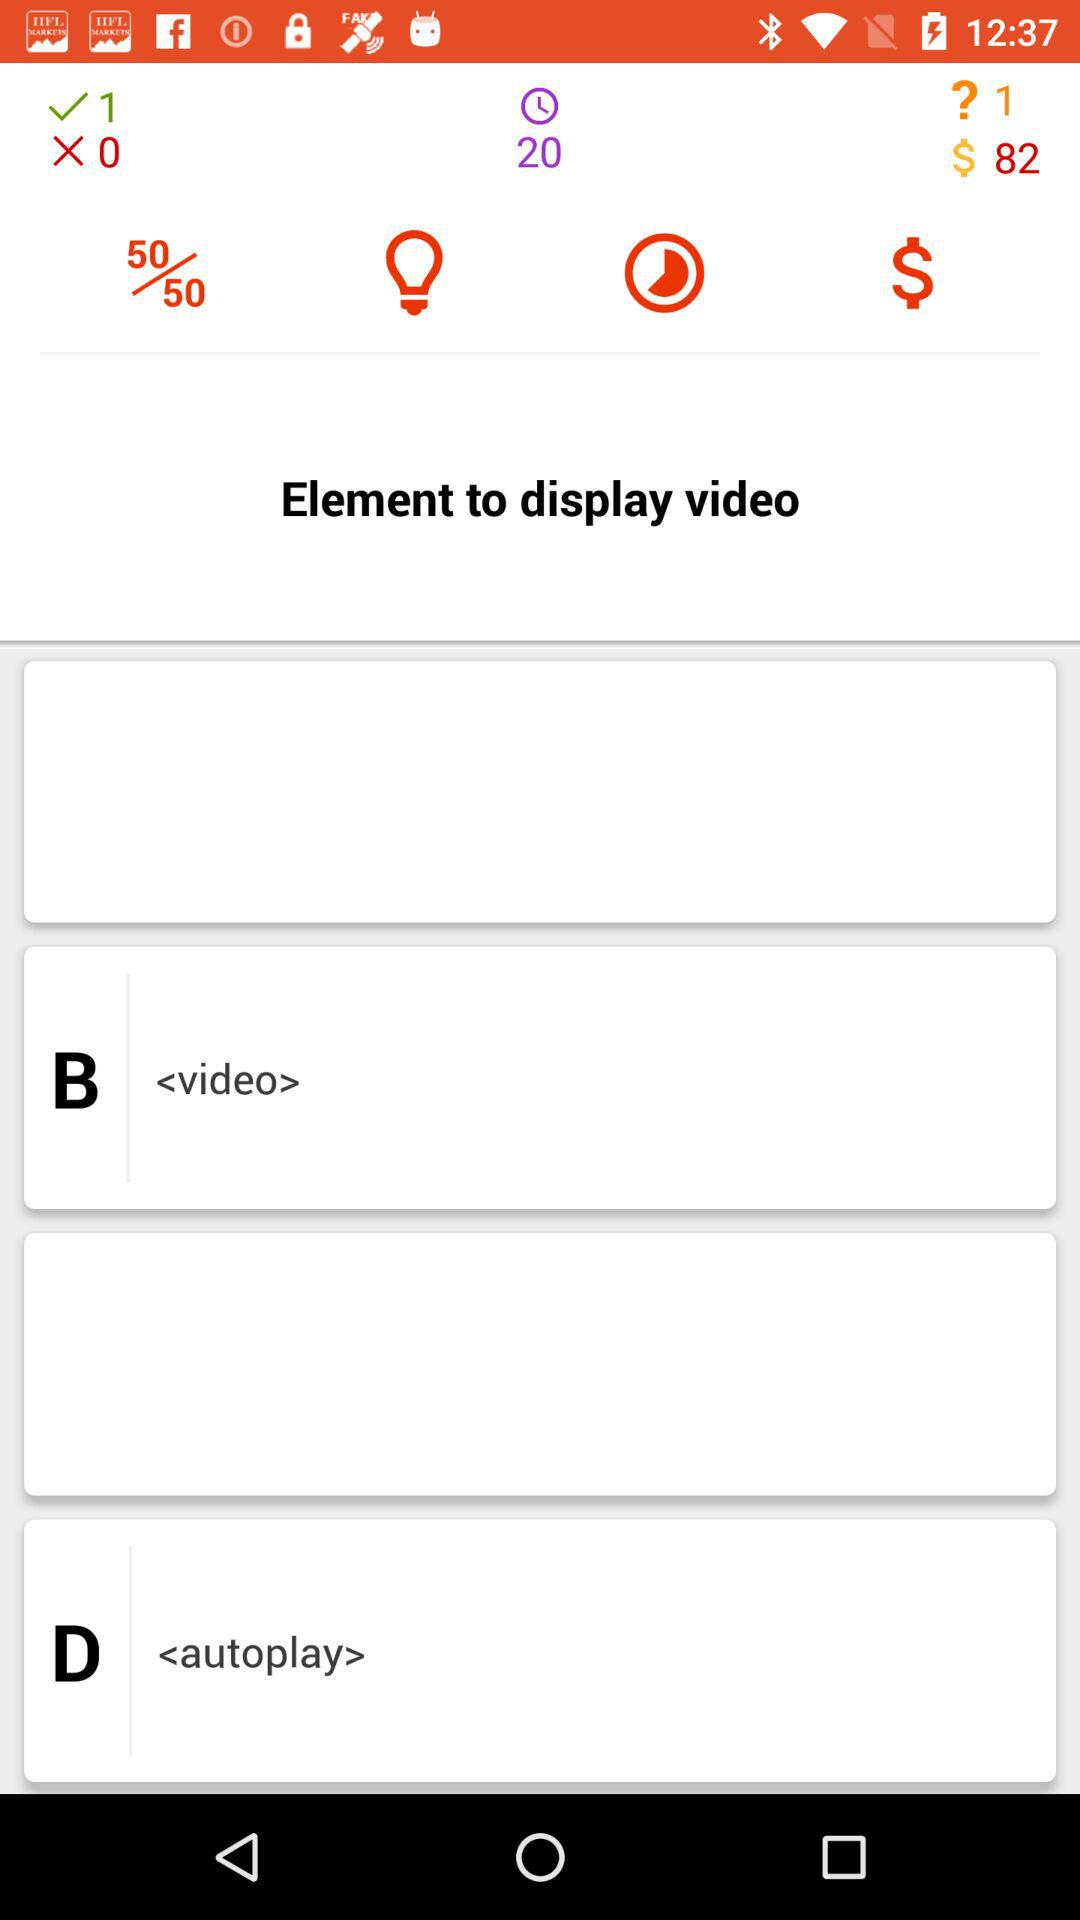What is the given total time duration? The given total time duration is 20. 